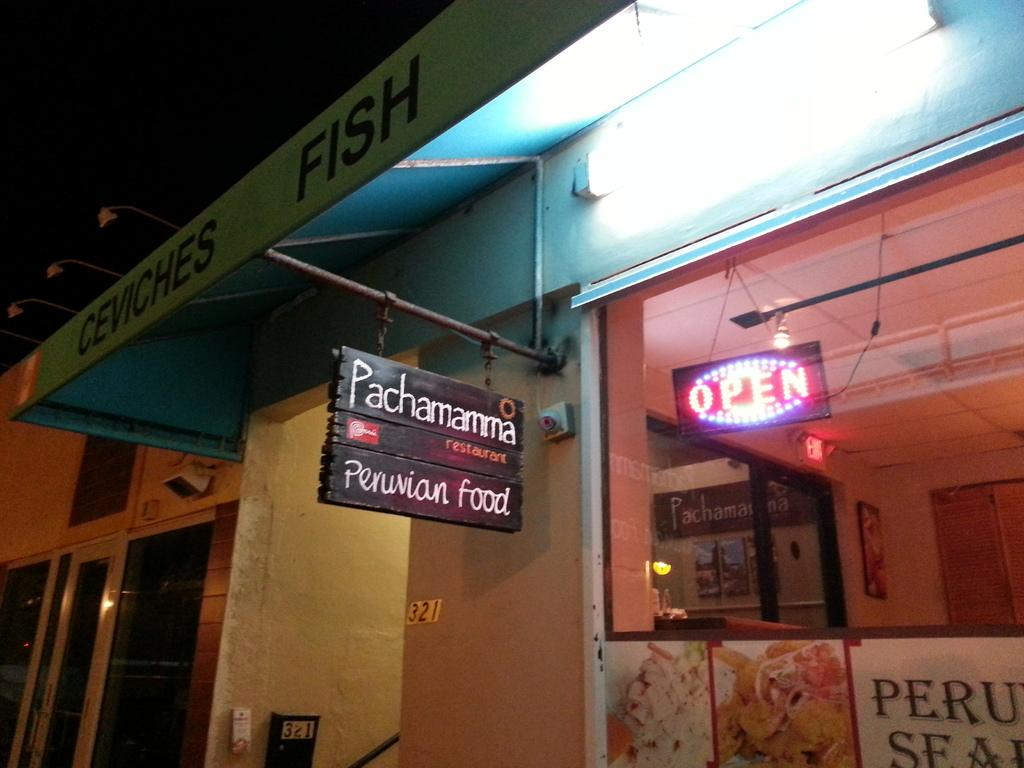<image>
Summarize the visual content of the image. A restaurant called Pachamamma serves Peruvian food and has an "open" sign lit up. 